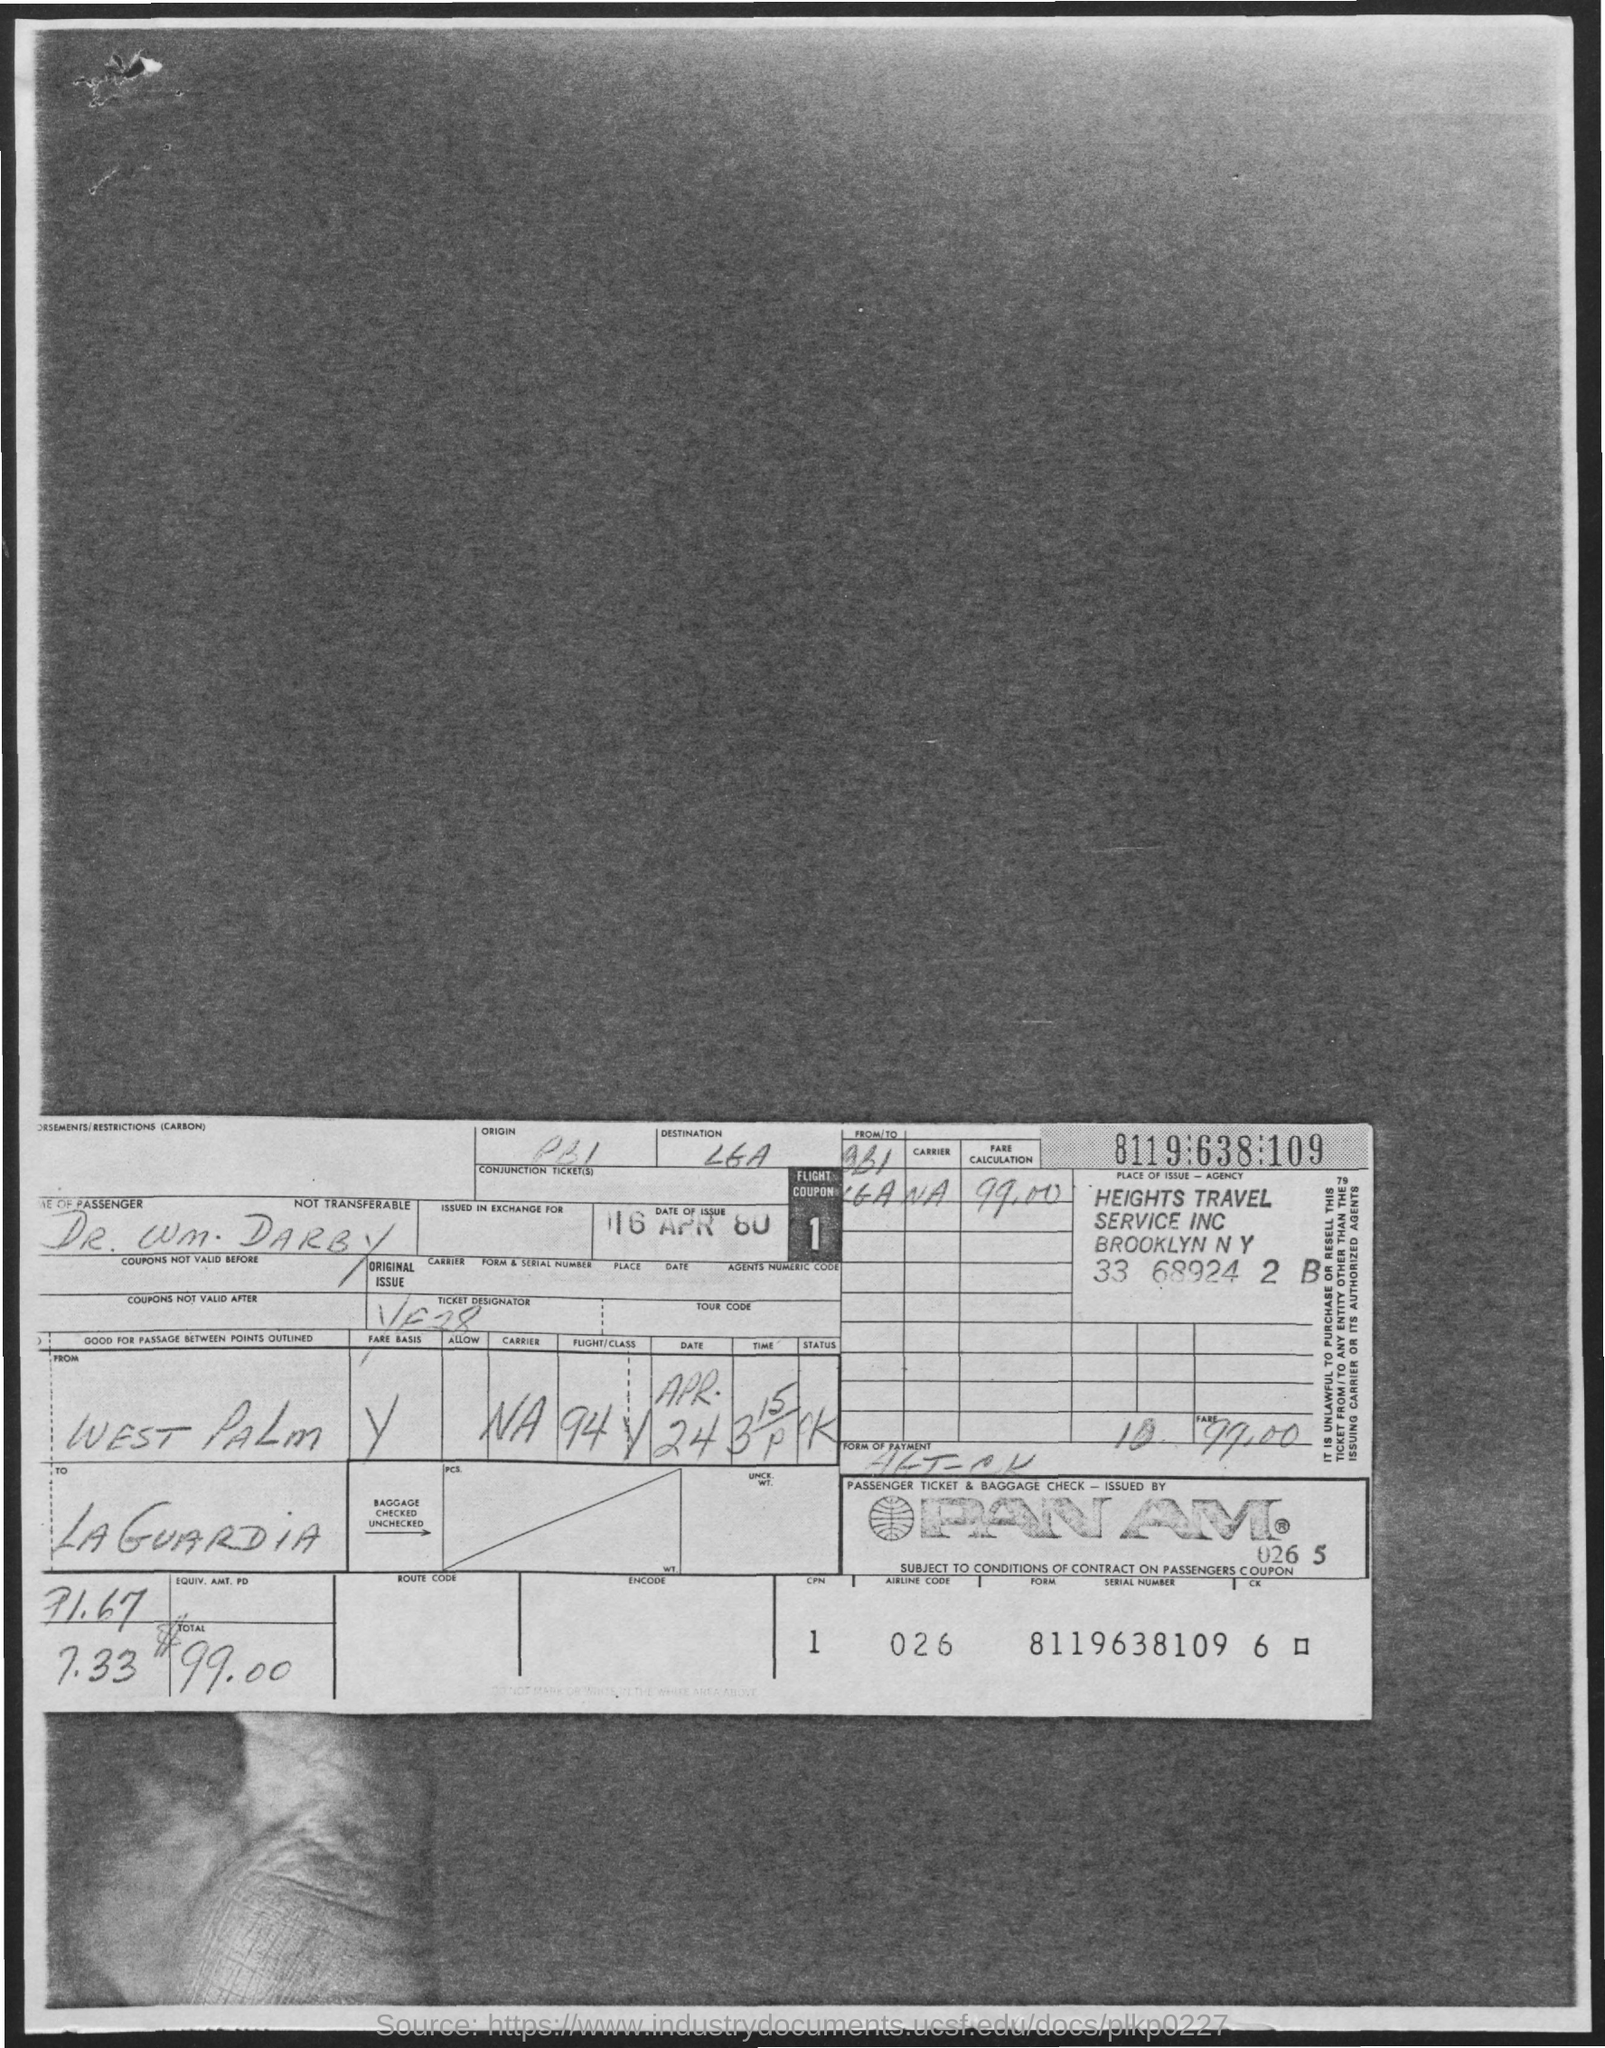Highlight a few significant elements in this photo. The name of the departure station in West Palm Beach is... Can you please provide the serial number for Form 8119638109, revision 6? The passenger's name is Dr. Wm. Darby. The total amount is $99.00. The airline code is 026. 